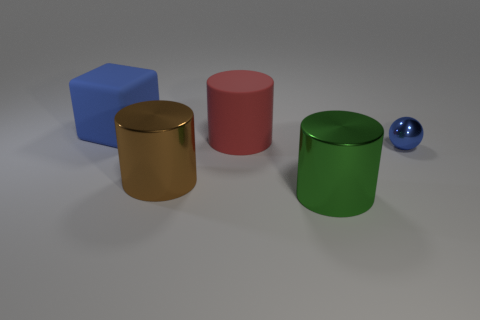Add 4 large purple cylinders. How many objects exist? 9 Subtract all cubes. How many objects are left? 4 Add 3 large blue rubber things. How many large blue rubber things exist? 4 Subtract 0 red spheres. How many objects are left? 5 Subtract all large brown rubber cylinders. Subtract all brown shiny cylinders. How many objects are left? 4 Add 4 large green shiny things. How many large green shiny things are left? 5 